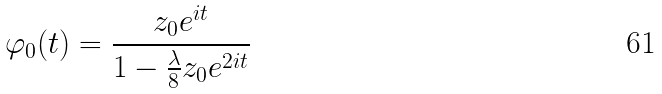Convert formula to latex. <formula><loc_0><loc_0><loc_500><loc_500>\varphi _ { 0 } ( t ) = { \frac { z _ { 0 } e ^ { i t } } { 1 - { \frac { \lambda } { 8 } } z _ { 0 } e ^ { 2 i t } } }</formula> 